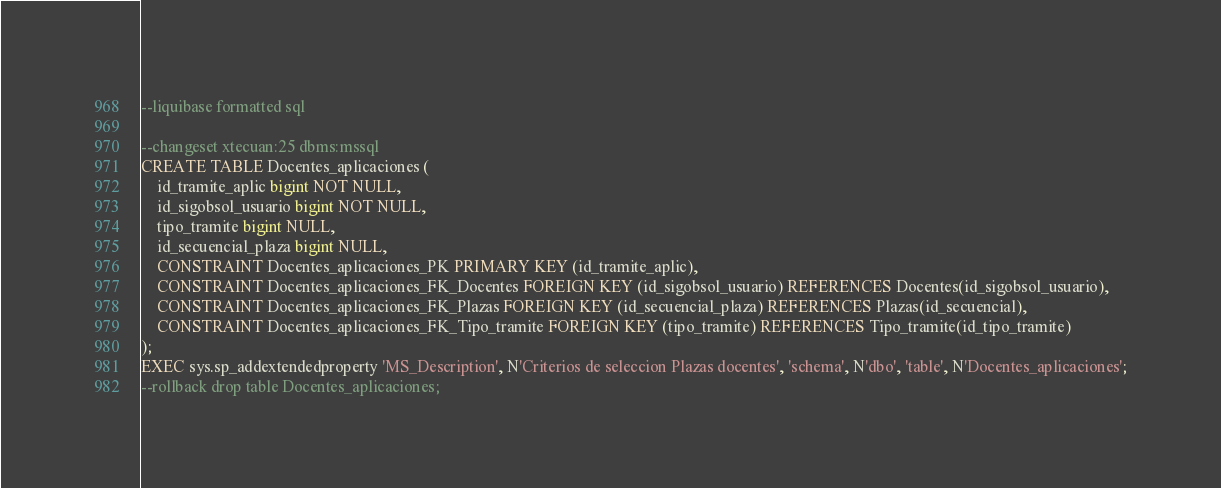Convert code to text. <code><loc_0><loc_0><loc_500><loc_500><_SQL_>--liquibase formatted sql

--changeset xtecuan:25 dbms:mssql
CREATE TABLE Docentes_aplicaciones (
	id_tramite_aplic bigint NOT NULL,
	id_sigobsol_usuario bigint NOT NULL,
	tipo_tramite bigint NULL,
	id_secuencial_plaza bigint NULL,
	CONSTRAINT Docentes_aplicaciones_PK PRIMARY KEY (id_tramite_aplic),
	CONSTRAINT Docentes_aplicaciones_FK_Docentes FOREIGN KEY (id_sigobsol_usuario) REFERENCES Docentes(id_sigobsol_usuario),
	CONSTRAINT Docentes_aplicaciones_FK_Plazas FOREIGN KEY (id_secuencial_plaza) REFERENCES Plazas(id_secuencial),
	CONSTRAINT Docentes_aplicaciones_FK_Tipo_tramite FOREIGN KEY (tipo_tramite) REFERENCES Tipo_tramite(id_tipo_tramite)
);
EXEC sys.sp_addextendedproperty 'MS_Description', N'Criterios de seleccion Plazas docentes', 'schema', N'dbo', 'table', N'Docentes_aplicaciones';
--rollback drop table Docentes_aplicaciones;  </code> 